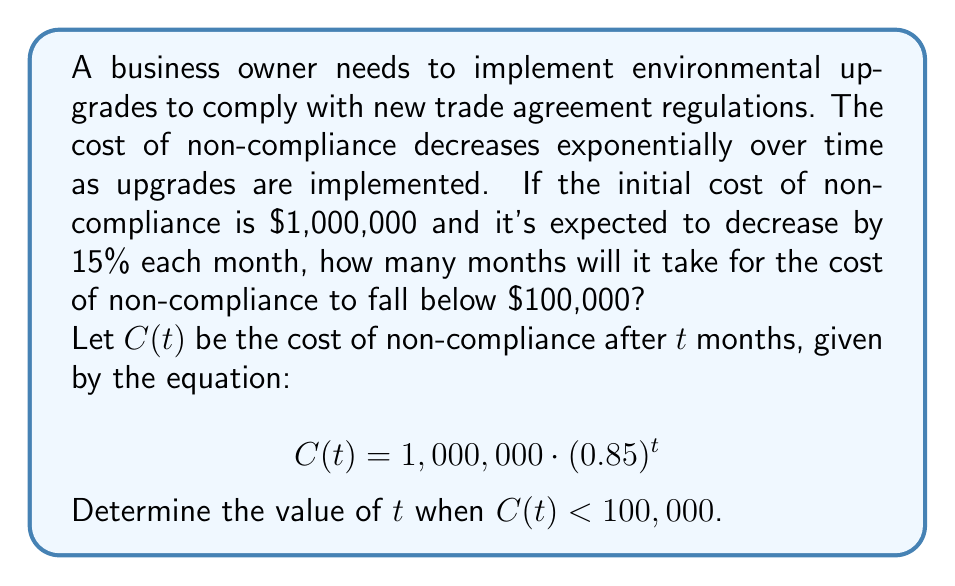What is the answer to this math problem? To solve this problem, we'll use the properties of logarithms:

1) First, we set up the inequality:
   $$1,000,000 \cdot (0.85)^t < 100,000$$

2) Divide both sides by 1,000,000:
   $$(0.85)^t < 0.1$$

3) Take the natural logarithm of both sides:
   $$\ln((0.85)^t) < \ln(0.1)$$

4) Use the logarithm property $\ln(a^b) = b\ln(a)$:
   $$t \cdot \ln(0.85) < \ln(0.1)$$

5) Divide both sides by $\ln(0.85)$ (note that $\ln(0.85)$ is negative, so the inequality sign flips):
   $$t > \frac{\ln(0.1)}{\ln(0.85)}$$

6) Calculate the right-hand side:
   $$t > \frac{\ln(0.1)}{\ln(0.85)} \approx 14.9067$$

7) Since $t$ represents months and must be a whole number, we round up to the next integer.
Answer: 15 months 